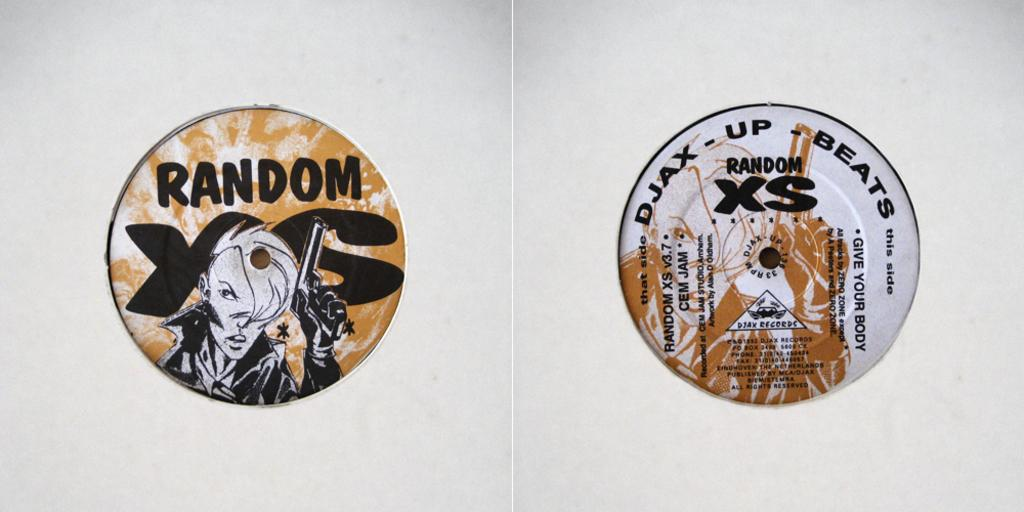<image>
Give a short and clear explanation of the subsequent image. Two circle pieces say random and one has DJAX Up Beats at the top. 